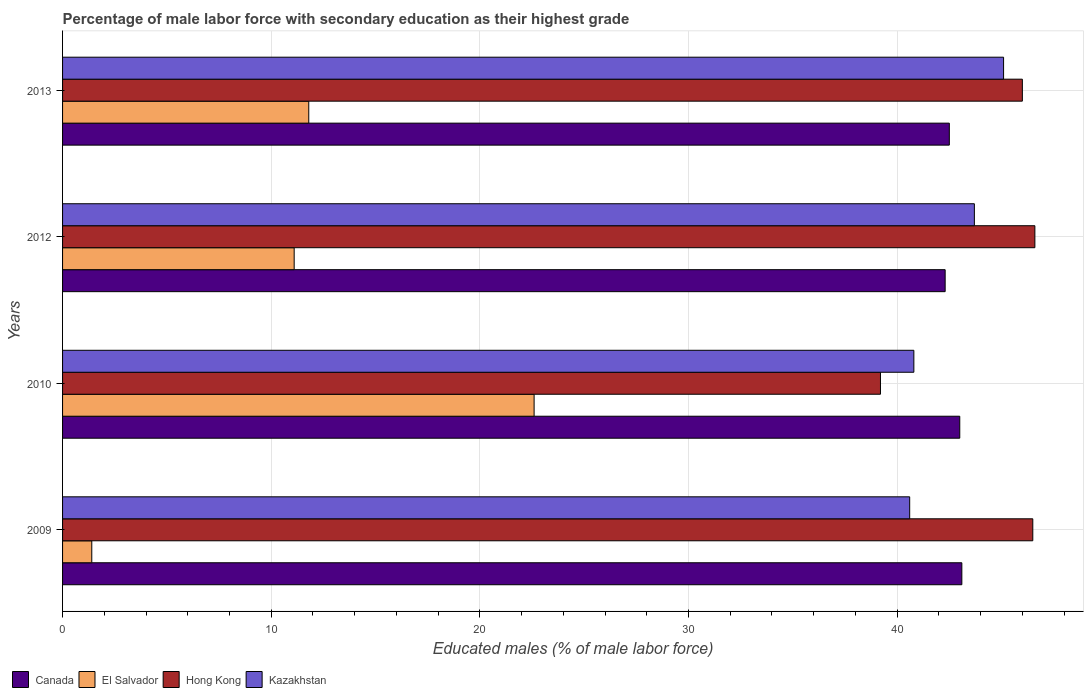How many different coloured bars are there?
Your response must be concise. 4. Are the number of bars per tick equal to the number of legend labels?
Your response must be concise. Yes. Are the number of bars on each tick of the Y-axis equal?
Your answer should be very brief. Yes. How many bars are there on the 1st tick from the top?
Your answer should be very brief. 4. What is the percentage of male labor force with secondary education in El Salvador in 2010?
Your answer should be compact. 22.6. Across all years, what is the maximum percentage of male labor force with secondary education in Canada?
Your answer should be compact. 43.1. Across all years, what is the minimum percentage of male labor force with secondary education in Kazakhstan?
Make the answer very short. 40.6. In which year was the percentage of male labor force with secondary education in Hong Kong maximum?
Ensure brevity in your answer.  2012. What is the total percentage of male labor force with secondary education in El Salvador in the graph?
Give a very brief answer. 46.9. What is the difference between the percentage of male labor force with secondary education in El Salvador in 2009 and the percentage of male labor force with secondary education in Hong Kong in 2013?
Provide a succinct answer. -44.6. What is the average percentage of male labor force with secondary education in El Salvador per year?
Provide a short and direct response. 11.73. In the year 2012, what is the difference between the percentage of male labor force with secondary education in Hong Kong and percentage of male labor force with secondary education in Kazakhstan?
Provide a short and direct response. 2.9. In how many years, is the percentage of male labor force with secondary education in Kazakhstan greater than 4 %?
Ensure brevity in your answer.  4. What is the ratio of the percentage of male labor force with secondary education in Hong Kong in 2010 to that in 2012?
Your response must be concise. 0.84. Is the difference between the percentage of male labor force with secondary education in Hong Kong in 2010 and 2013 greater than the difference between the percentage of male labor force with secondary education in Kazakhstan in 2010 and 2013?
Offer a terse response. No. What is the difference between the highest and the second highest percentage of male labor force with secondary education in El Salvador?
Provide a short and direct response. 10.8. What is the difference between the highest and the lowest percentage of male labor force with secondary education in Canada?
Offer a very short reply. 0.8. What does the 3rd bar from the top in 2012 represents?
Ensure brevity in your answer.  El Salvador. What does the 4th bar from the bottom in 2010 represents?
Offer a terse response. Kazakhstan. Is it the case that in every year, the sum of the percentage of male labor force with secondary education in Hong Kong and percentage of male labor force with secondary education in Canada is greater than the percentage of male labor force with secondary education in El Salvador?
Give a very brief answer. Yes. Are all the bars in the graph horizontal?
Provide a succinct answer. Yes. What is the difference between two consecutive major ticks on the X-axis?
Offer a very short reply. 10. Does the graph contain any zero values?
Offer a very short reply. No. Where does the legend appear in the graph?
Offer a very short reply. Bottom left. How many legend labels are there?
Provide a succinct answer. 4. How are the legend labels stacked?
Make the answer very short. Horizontal. What is the title of the graph?
Provide a short and direct response. Percentage of male labor force with secondary education as their highest grade. What is the label or title of the X-axis?
Ensure brevity in your answer.  Educated males (% of male labor force). What is the Educated males (% of male labor force) of Canada in 2009?
Ensure brevity in your answer.  43.1. What is the Educated males (% of male labor force) of El Salvador in 2009?
Provide a succinct answer. 1.4. What is the Educated males (% of male labor force) in Hong Kong in 2009?
Ensure brevity in your answer.  46.5. What is the Educated males (% of male labor force) in Kazakhstan in 2009?
Ensure brevity in your answer.  40.6. What is the Educated males (% of male labor force) in El Salvador in 2010?
Ensure brevity in your answer.  22.6. What is the Educated males (% of male labor force) of Hong Kong in 2010?
Provide a succinct answer. 39.2. What is the Educated males (% of male labor force) of Kazakhstan in 2010?
Keep it short and to the point. 40.8. What is the Educated males (% of male labor force) in Canada in 2012?
Your answer should be very brief. 42.3. What is the Educated males (% of male labor force) in El Salvador in 2012?
Make the answer very short. 11.1. What is the Educated males (% of male labor force) in Hong Kong in 2012?
Provide a succinct answer. 46.6. What is the Educated males (% of male labor force) in Kazakhstan in 2012?
Ensure brevity in your answer.  43.7. What is the Educated males (% of male labor force) in Canada in 2013?
Offer a very short reply. 42.5. What is the Educated males (% of male labor force) of El Salvador in 2013?
Provide a succinct answer. 11.8. What is the Educated males (% of male labor force) in Kazakhstan in 2013?
Offer a terse response. 45.1. Across all years, what is the maximum Educated males (% of male labor force) of Canada?
Your answer should be compact. 43.1. Across all years, what is the maximum Educated males (% of male labor force) in El Salvador?
Offer a terse response. 22.6. Across all years, what is the maximum Educated males (% of male labor force) of Hong Kong?
Your response must be concise. 46.6. Across all years, what is the maximum Educated males (% of male labor force) of Kazakhstan?
Your response must be concise. 45.1. Across all years, what is the minimum Educated males (% of male labor force) in Canada?
Your response must be concise. 42.3. Across all years, what is the minimum Educated males (% of male labor force) of El Salvador?
Offer a very short reply. 1.4. Across all years, what is the minimum Educated males (% of male labor force) in Hong Kong?
Offer a very short reply. 39.2. Across all years, what is the minimum Educated males (% of male labor force) of Kazakhstan?
Your answer should be very brief. 40.6. What is the total Educated males (% of male labor force) of Canada in the graph?
Your answer should be very brief. 170.9. What is the total Educated males (% of male labor force) of El Salvador in the graph?
Offer a terse response. 46.9. What is the total Educated males (% of male labor force) of Hong Kong in the graph?
Your answer should be compact. 178.3. What is the total Educated males (% of male labor force) of Kazakhstan in the graph?
Provide a succinct answer. 170.2. What is the difference between the Educated males (% of male labor force) in Canada in 2009 and that in 2010?
Provide a succinct answer. 0.1. What is the difference between the Educated males (% of male labor force) of El Salvador in 2009 and that in 2010?
Ensure brevity in your answer.  -21.2. What is the difference between the Educated males (% of male labor force) in Canada in 2009 and that in 2012?
Your answer should be very brief. 0.8. What is the difference between the Educated males (% of male labor force) in Hong Kong in 2009 and that in 2012?
Make the answer very short. -0.1. What is the difference between the Educated males (% of male labor force) in Kazakhstan in 2009 and that in 2012?
Give a very brief answer. -3.1. What is the difference between the Educated males (% of male labor force) of Canada in 2009 and that in 2013?
Give a very brief answer. 0.6. What is the difference between the Educated males (% of male labor force) of Kazakhstan in 2009 and that in 2013?
Offer a very short reply. -4.5. What is the difference between the Educated males (% of male labor force) of Canada in 2010 and that in 2012?
Give a very brief answer. 0.7. What is the difference between the Educated males (% of male labor force) of El Salvador in 2010 and that in 2012?
Your answer should be very brief. 11.5. What is the difference between the Educated males (% of male labor force) of Hong Kong in 2010 and that in 2012?
Your response must be concise. -7.4. What is the difference between the Educated males (% of male labor force) of Kazakhstan in 2010 and that in 2012?
Ensure brevity in your answer.  -2.9. What is the difference between the Educated males (% of male labor force) in El Salvador in 2010 and that in 2013?
Provide a short and direct response. 10.8. What is the difference between the Educated males (% of male labor force) of Hong Kong in 2010 and that in 2013?
Give a very brief answer. -6.8. What is the difference between the Educated males (% of male labor force) in Kazakhstan in 2010 and that in 2013?
Provide a succinct answer. -4.3. What is the difference between the Educated males (% of male labor force) of Canada in 2012 and that in 2013?
Offer a very short reply. -0.2. What is the difference between the Educated males (% of male labor force) of El Salvador in 2012 and that in 2013?
Your answer should be compact. -0.7. What is the difference between the Educated males (% of male labor force) in Hong Kong in 2012 and that in 2013?
Provide a short and direct response. 0.6. What is the difference between the Educated males (% of male labor force) of Kazakhstan in 2012 and that in 2013?
Provide a short and direct response. -1.4. What is the difference between the Educated males (% of male labor force) of Canada in 2009 and the Educated males (% of male labor force) of El Salvador in 2010?
Your answer should be very brief. 20.5. What is the difference between the Educated males (% of male labor force) of Canada in 2009 and the Educated males (% of male labor force) of Hong Kong in 2010?
Ensure brevity in your answer.  3.9. What is the difference between the Educated males (% of male labor force) in El Salvador in 2009 and the Educated males (% of male labor force) in Hong Kong in 2010?
Provide a succinct answer. -37.8. What is the difference between the Educated males (% of male labor force) in El Salvador in 2009 and the Educated males (% of male labor force) in Kazakhstan in 2010?
Provide a succinct answer. -39.4. What is the difference between the Educated males (% of male labor force) of Canada in 2009 and the Educated males (% of male labor force) of Kazakhstan in 2012?
Your answer should be compact. -0.6. What is the difference between the Educated males (% of male labor force) in El Salvador in 2009 and the Educated males (% of male labor force) in Hong Kong in 2012?
Ensure brevity in your answer.  -45.2. What is the difference between the Educated males (% of male labor force) in El Salvador in 2009 and the Educated males (% of male labor force) in Kazakhstan in 2012?
Your answer should be very brief. -42.3. What is the difference between the Educated males (% of male labor force) of Canada in 2009 and the Educated males (% of male labor force) of El Salvador in 2013?
Make the answer very short. 31.3. What is the difference between the Educated males (% of male labor force) in El Salvador in 2009 and the Educated males (% of male labor force) in Hong Kong in 2013?
Ensure brevity in your answer.  -44.6. What is the difference between the Educated males (% of male labor force) of El Salvador in 2009 and the Educated males (% of male labor force) of Kazakhstan in 2013?
Offer a terse response. -43.7. What is the difference between the Educated males (% of male labor force) in Canada in 2010 and the Educated males (% of male labor force) in El Salvador in 2012?
Give a very brief answer. 31.9. What is the difference between the Educated males (% of male labor force) in El Salvador in 2010 and the Educated males (% of male labor force) in Kazakhstan in 2012?
Provide a short and direct response. -21.1. What is the difference between the Educated males (% of male labor force) in Hong Kong in 2010 and the Educated males (% of male labor force) in Kazakhstan in 2012?
Give a very brief answer. -4.5. What is the difference between the Educated males (% of male labor force) of Canada in 2010 and the Educated males (% of male labor force) of El Salvador in 2013?
Give a very brief answer. 31.2. What is the difference between the Educated males (% of male labor force) in Canada in 2010 and the Educated males (% of male labor force) in Kazakhstan in 2013?
Your answer should be very brief. -2.1. What is the difference between the Educated males (% of male labor force) of El Salvador in 2010 and the Educated males (% of male labor force) of Hong Kong in 2013?
Offer a very short reply. -23.4. What is the difference between the Educated males (% of male labor force) of El Salvador in 2010 and the Educated males (% of male labor force) of Kazakhstan in 2013?
Your answer should be compact. -22.5. What is the difference between the Educated males (% of male labor force) of Canada in 2012 and the Educated males (% of male labor force) of El Salvador in 2013?
Offer a very short reply. 30.5. What is the difference between the Educated males (% of male labor force) in El Salvador in 2012 and the Educated males (% of male labor force) in Hong Kong in 2013?
Ensure brevity in your answer.  -34.9. What is the difference between the Educated males (% of male labor force) of El Salvador in 2012 and the Educated males (% of male labor force) of Kazakhstan in 2013?
Your answer should be very brief. -34. What is the average Educated males (% of male labor force) of Canada per year?
Provide a short and direct response. 42.73. What is the average Educated males (% of male labor force) in El Salvador per year?
Offer a terse response. 11.72. What is the average Educated males (% of male labor force) of Hong Kong per year?
Offer a terse response. 44.58. What is the average Educated males (% of male labor force) of Kazakhstan per year?
Make the answer very short. 42.55. In the year 2009, what is the difference between the Educated males (% of male labor force) of Canada and Educated males (% of male labor force) of El Salvador?
Offer a terse response. 41.7. In the year 2009, what is the difference between the Educated males (% of male labor force) of Canada and Educated males (% of male labor force) of Kazakhstan?
Offer a terse response. 2.5. In the year 2009, what is the difference between the Educated males (% of male labor force) in El Salvador and Educated males (% of male labor force) in Hong Kong?
Give a very brief answer. -45.1. In the year 2009, what is the difference between the Educated males (% of male labor force) in El Salvador and Educated males (% of male labor force) in Kazakhstan?
Provide a short and direct response. -39.2. In the year 2010, what is the difference between the Educated males (% of male labor force) in Canada and Educated males (% of male labor force) in El Salvador?
Offer a terse response. 20.4. In the year 2010, what is the difference between the Educated males (% of male labor force) of Canada and Educated males (% of male labor force) of Hong Kong?
Offer a very short reply. 3.8. In the year 2010, what is the difference between the Educated males (% of male labor force) in Canada and Educated males (% of male labor force) in Kazakhstan?
Give a very brief answer. 2.2. In the year 2010, what is the difference between the Educated males (% of male labor force) of El Salvador and Educated males (% of male labor force) of Hong Kong?
Offer a very short reply. -16.6. In the year 2010, what is the difference between the Educated males (% of male labor force) in El Salvador and Educated males (% of male labor force) in Kazakhstan?
Provide a succinct answer. -18.2. In the year 2010, what is the difference between the Educated males (% of male labor force) in Hong Kong and Educated males (% of male labor force) in Kazakhstan?
Provide a short and direct response. -1.6. In the year 2012, what is the difference between the Educated males (% of male labor force) in Canada and Educated males (% of male labor force) in El Salvador?
Offer a terse response. 31.2. In the year 2012, what is the difference between the Educated males (% of male labor force) of Canada and Educated males (% of male labor force) of Kazakhstan?
Provide a short and direct response. -1.4. In the year 2012, what is the difference between the Educated males (% of male labor force) in El Salvador and Educated males (% of male labor force) in Hong Kong?
Provide a succinct answer. -35.5. In the year 2012, what is the difference between the Educated males (% of male labor force) in El Salvador and Educated males (% of male labor force) in Kazakhstan?
Provide a short and direct response. -32.6. In the year 2012, what is the difference between the Educated males (% of male labor force) of Hong Kong and Educated males (% of male labor force) of Kazakhstan?
Provide a short and direct response. 2.9. In the year 2013, what is the difference between the Educated males (% of male labor force) of Canada and Educated males (% of male labor force) of El Salvador?
Give a very brief answer. 30.7. In the year 2013, what is the difference between the Educated males (% of male labor force) of Canada and Educated males (% of male labor force) of Hong Kong?
Offer a terse response. -3.5. In the year 2013, what is the difference between the Educated males (% of male labor force) in Canada and Educated males (% of male labor force) in Kazakhstan?
Your answer should be compact. -2.6. In the year 2013, what is the difference between the Educated males (% of male labor force) in El Salvador and Educated males (% of male labor force) in Hong Kong?
Your response must be concise. -34.2. In the year 2013, what is the difference between the Educated males (% of male labor force) of El Salvador and Educated males (% of male labor force) of Kazakhstan?
Your answer should be very brief. -33.3. In the year 2013, what is the difference between the Educated males (% of male labor force) of Hong Kong and Educated males (% of male labor force) of Kazakhstan?
Your response must be concise. 0.9. What is the ratio of the Educated males (% of male labor force) in Canada in 2009 to that in 2010?
Offer a terse response. 1. What is the ratio of the Educated males (% of male labor force) of El Salvador in 2009 to that in 2010?
Your answer should be very brief. 0.06. What is the ratio of the Educated males (% of male labor force) in Hong Kong in 2009 to that in 2010?
Offer a terse response. 1.19. What is the ratio of the Educated males (% of male labor force) of Canada in 2009 to that in 2012?
Offer a terse response. 1.02. What is the ratio of the Educated males (% of male labor force) in El Salvador in 2009 to that in 2012?
Provide a succinct answer. 0.13. What is the ratio of the Educated males (% of male labor force) in Hong Kong in 2009 to that in 2012?
Provide a succinct answer. 1. What is the ratio of the Educated males (% of male labor force) of Kazakhstan in 2009 to that in 2012?
Give a very brief answer. 0.93. What is the ratio of the Educated males (% of male labor force) of Canada in 2009 to that in 2013?
Give a very brief answer. 1.01. What is the ratio of the Educated males (% of male labor force) of El Salvador in 2009 to that in 2013?
Give a very brief answer. 0.12. What is the ratio of the Educated males (% of male labor force) in Hong Kong in 2009 to that in 2013?
Ensure brevity in your answer.  1.01. What is the ratio of the Educated males (% of male labor force) of Kazakhstan in 2009 to that in 2013?
Offer a terse response. 0.9. What is the ratio of the Educated males (% of male labor force) in Canada in 2010 to that in 2012?
Provide a short and direct response. 1.02. What is the ratio of the Educated males (% of male labor force) of El Salvador in 2010 to that in 2012?
Give a very brief answer. 2.04. What is the ratio of the Educated males (% of male labor force) in Hong Kong in 2010 to that in 2012?
Provide a succinct answer. 0.84. What is the ratio of the Educated males (% of male labor force) in Kazakhstan in 2010 to that in 2012?
Provide a short and direct response. 0.93. What is the ratio of the Educated males (% of male labor force) of Canada in 2010 to that in 2013?
Offer a terse response. 1.01. What is the ratio of the Educated males (% of male labor force) in El Salvador in 2010 to that in 2013?
Provide a short and direct response. 1.92. What is the ratio of the Educated males (% of male labor force) of Hong Kong in 2010 to that in 2013?
Offer a very short reply. 0.85. What is the ratio of the Educated males (% of male labor force) in Kazakhstan in 2010 to that in 2013?
Ensure brevity in your answer.  0.9. What is the ratio of the Educated males (% of male labor force) in Canada in 2012 to that in 2013?
Provide a succinct answer. 1. What is the ratio of the Educated males (% of male labor force) of El Salvador in 2012 to that in 2013?
Your answer should be very brief. 0.94. What is the ratio of the Educated males (% of male labor force) in Kazakhstan in 2012 to that in 2013?
Provide a succinct answer. 0.97. What is the difference between the highest and the second highest Educated males (% of male labor force) in Hong Kong?
Give a very brief answer. 0.1. What is the difference between the highest and the lowest Educated males (% of male labor force) of Canada?
Your answer should be compact. 0.8. What is the difference between the highest and the lowest Educated males (% of male labor force) of El Salvador?
Offer a terse response. 21.2. 